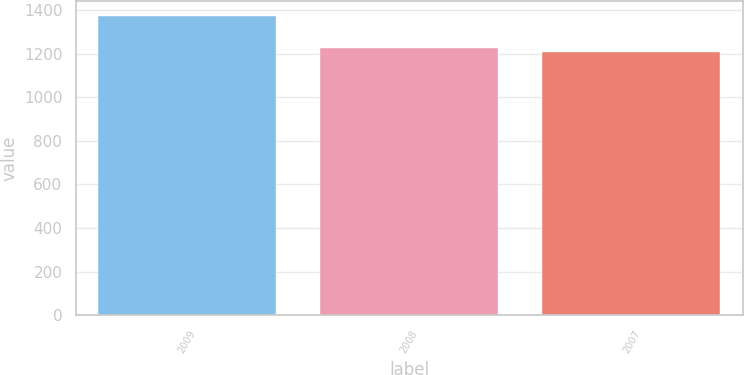Convert chart. <chart><loc_0><loc_0><loc_500><loc_500><bar_chart><fcel>2009<fcel>2008<fcel>2007<nl><fcel>1371<fcel>1224<fcel>1207<nl></chart> 